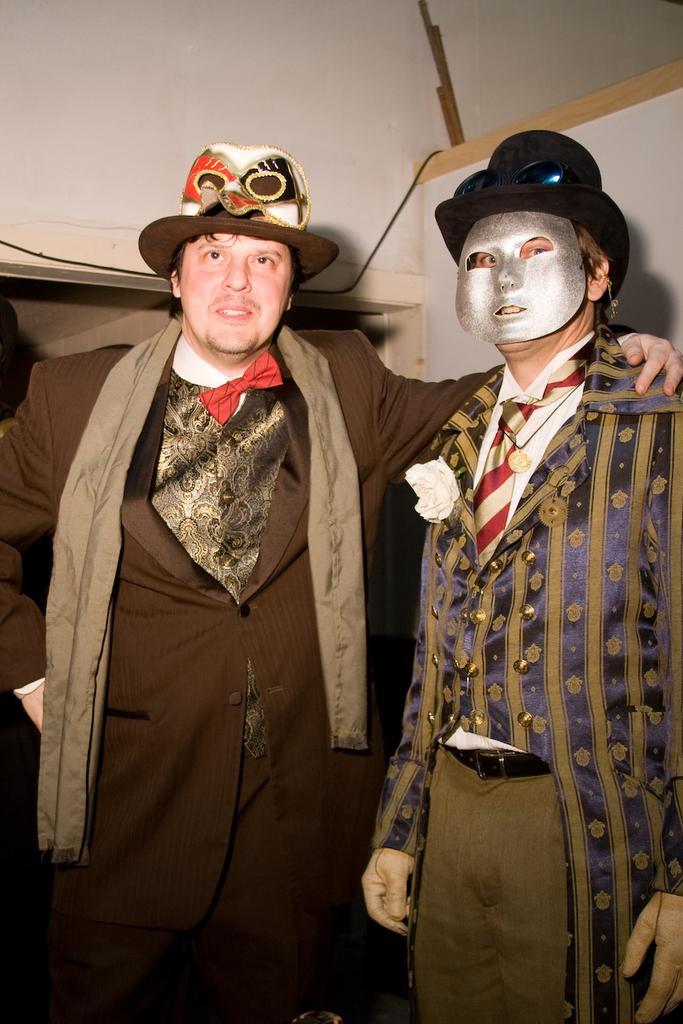Could you give a brief overview of what you see in this image? In this image I can see two men standing and giving pose for the picture. I can see the caps on their heads. The man who is on the right side is wearing a mask to his face. In the background, I can see a wall. 